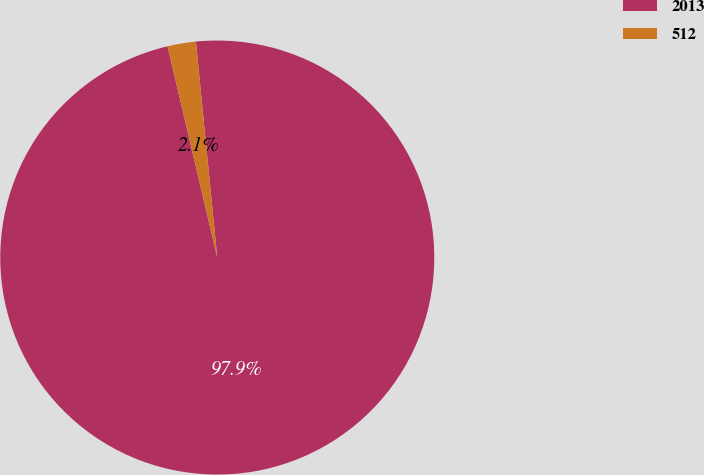Convert chart. <chart><loc_0><loc_0><loc_500><loc_500><pie_chart><fcel>2013<fcel>512<nl><fcel>97.89%<fcel>2.11%<nl></chart> 